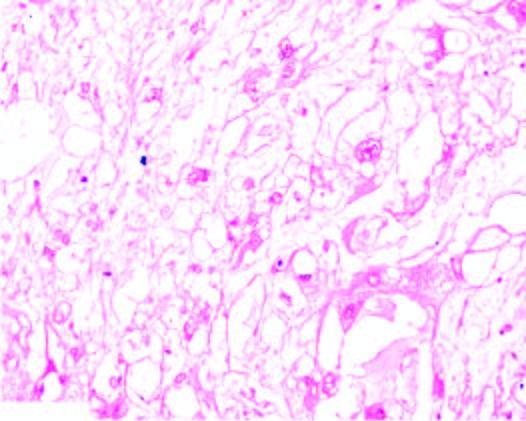what do the tumour cells have?
Answer the question using a single word or phrase. Characteristic bubbly cytoplasm and anisonucleocytosis 